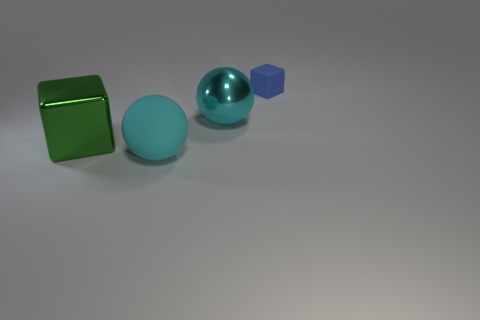Is there any other thing that has the same size as the blue thing?
Ensure brevity in your answer.  No. Is the color of the large rubber object the same as the metallic ball?
Provide a short and direct response. Yes. There is another ball that is the same color as the matte ball; what is it made of?
Your response must be concise. Metal. What size is the matte ball that is the same color as the large metal sphere?
Provide a short and direct response. Large. What color is the metallic object that is right of the cube that is in front of the blue matte thing?
Provide a short and direct response. Cyan. There is a object that is in front of the blue rubber thing and behind the large green block; how big is it?
Give a very brief answer. Large. How many other objects are there of the same shape as the blue rubber object?
Offer a very short reply. 1. Does the small blue rubber thing have the same shape as the object that is left of the large cyan rubber object?
Give a very brief answer. Yes. There is a large cyan rubber object; what number of blocks are to the right of it?
Give a very brief answer. 1. Is there any other thing that has the same material as the green object?
Offer a terse response. Yes. 